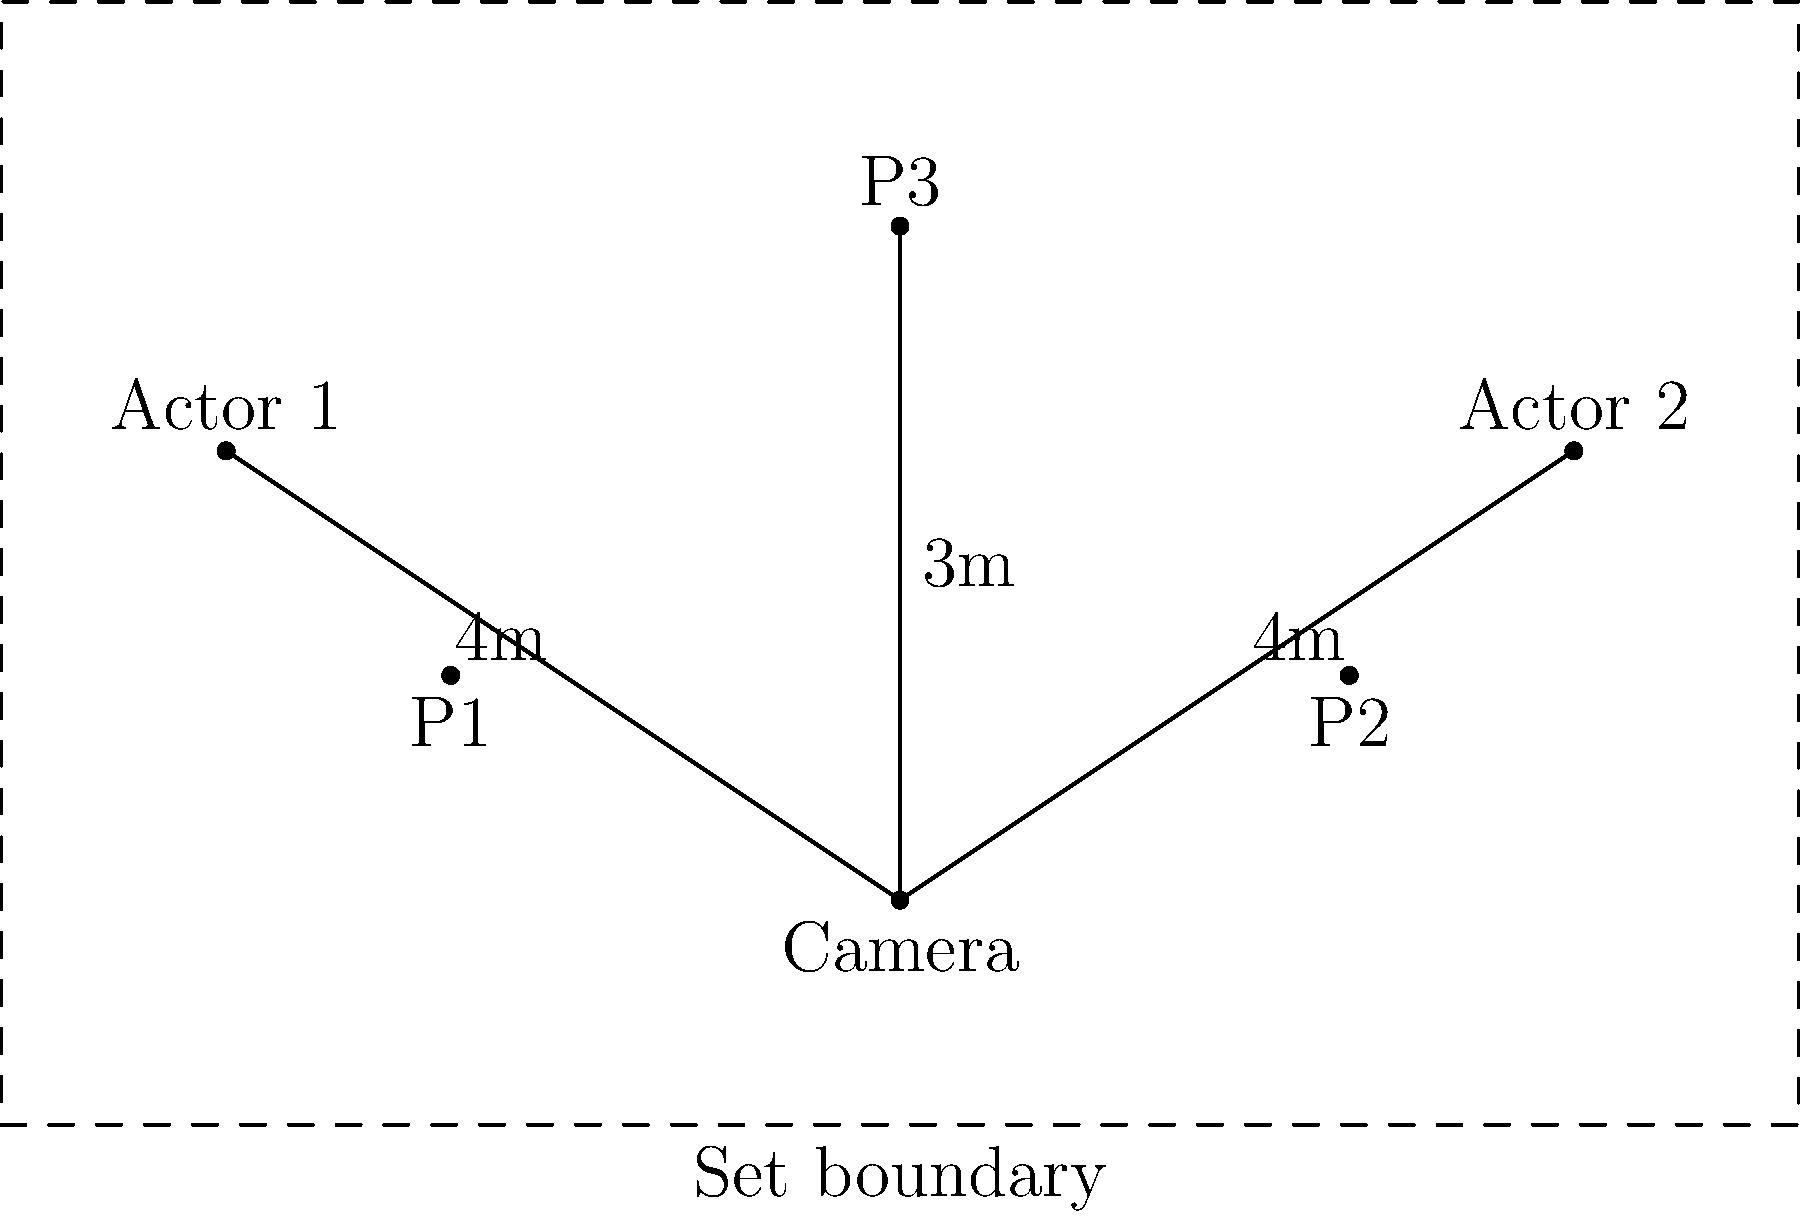In the given film set diagram, three pyrotechnic effects (P1, P2, and P3) have been placed. Considering safety regulations and visual impact, which pyrotechnic effect placement is most problematic and should be repositioned? Explain your reasoning based on the principles of practical effects and traditional filmmaking techniques. To determine the most problematic pyrotechnic effect placement, we need to consider several factors:

1. Safety: Pyrotechnics should be placed at a safe distance from actors and crew.
2. Visual impact: The effects should be visible and impactful on camera.
3. Realism: The placement should contribute to the scene's authenticity.
4. Camera angle: The effects should be positioned to work well with the camera's field of view.

Let's analyze each pyrotechnic placement:

P1 and P2:
- These are placed between the camera and the actors.
- They are closer to the camera than the actors, which may create a sense of depth and scale.
- Their position allows for a safe distance from the actors.

P3:
- This is placed behind and above both actors.
- It's directly in line with the camera's view.
- It's closer to the actors than P1 and P2.

Considering these factors, P3 is the most problematic placement because:

1. Safety: It's closer to the actors, potentially posing a higher risk.
2. Visual impact: Being directly behind the actors, it may be partially obscured or create an unrealistic halo effect.
3. Realism: The position might not contribute to the scene's authenticity, depending on the intended effect.
4. Camera angle: While it's in the camera's line of sight, it might appear too centered and artificial.

To improve the setup, P3 should be repositioned. Possible improvements include:
- Moving it to one side to create a more dynamic composition.
- Lowering it to be more in line with the actors for a more realistic effect.
- Placing it further back to increase safety and potentially create a larger, more impressive effect.
Answer: P3 should be repositioned due to safety concerns, potential visual obstruction, and unrealistic positioning relative to the actors and camera. 